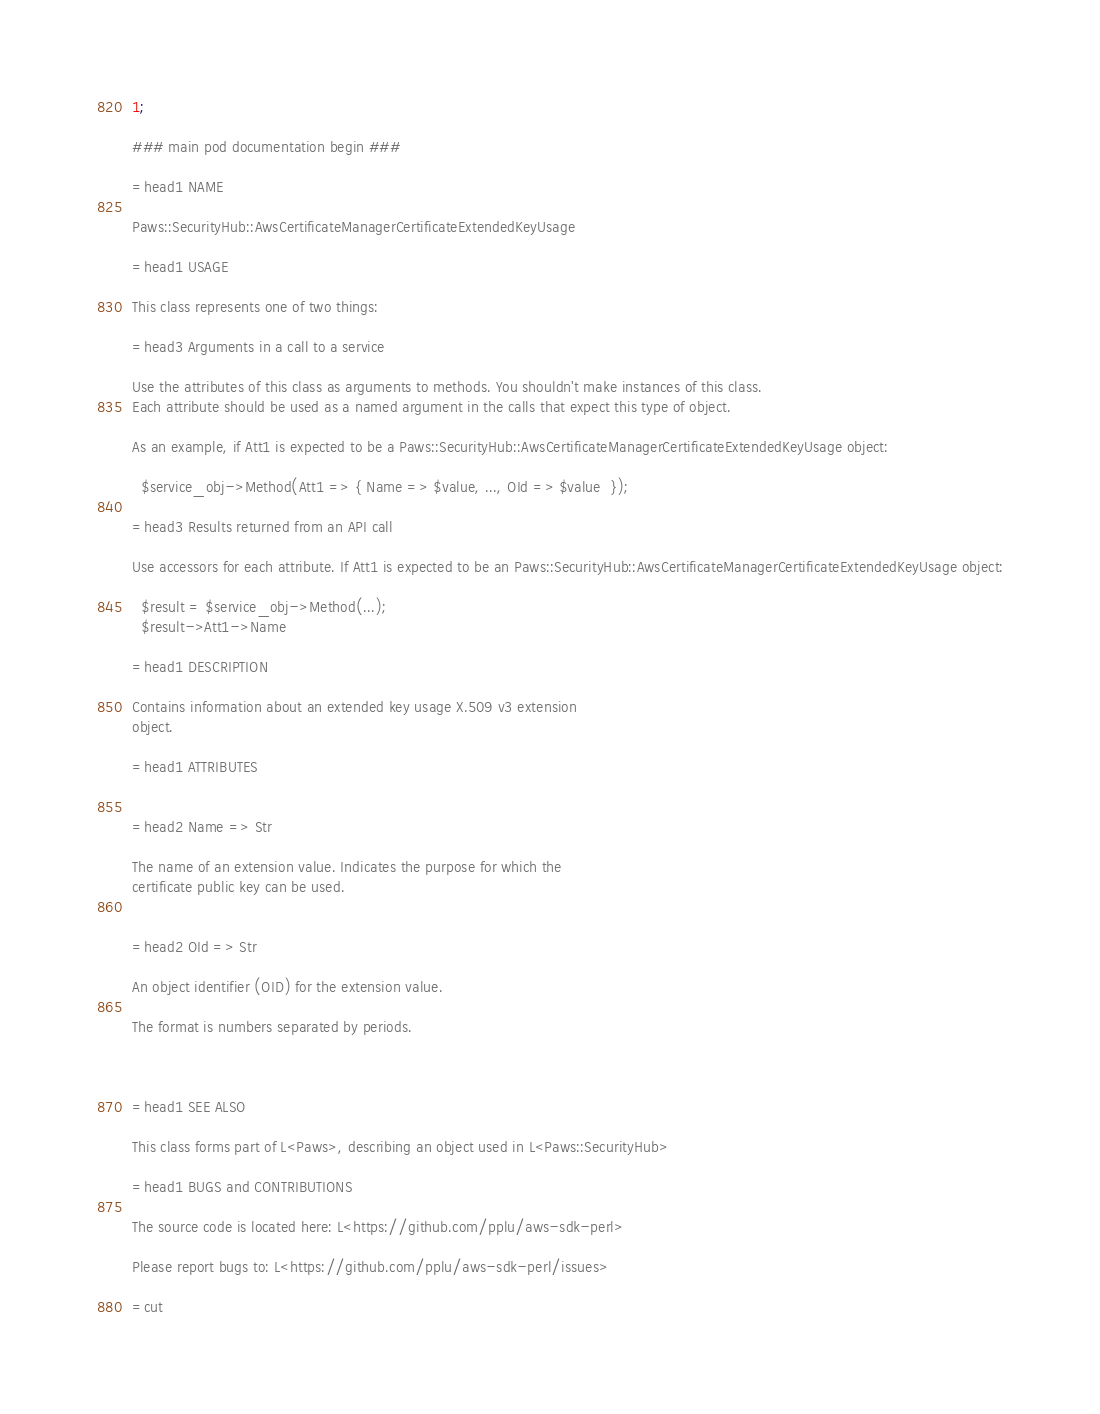<code> <loc_0><loc_0><loc_500><loc_500><_Perl_>1;

### main pod documentation begin ###

=head1 NAME

Paws::SecurityHub::AwsCertificateManagerCertificateExtendedKeyUsage

=head1 USAGE

This class represents one of two things:

=head3 Arguments in a call to a service

Use the attributes of this class as arguments to methods. You shouldn't make instances of this class. 
Each attribute should be used as a named argument in the calls that expect this type of object.

As an example, if Att1 is expected to be a Paws::SecurityHub::AwsCertificateManagerCertificateExtendedKeyUsage object:

  $service_obj->Method(Att1 => { Name => $value, ..., OId => $value  });

=head3 Results returned from an API call

Use accessors for each attribute. If Att1 is expected to be an Paws::SecurityHub::AwsCertificateManagerCertificateExtendedKeyUsage object:

  $result = $service_obj->Method(...);
  $result->Att1->Name

=head1 DESCRIPTION

Contains information about an extended key usage X.509 v3 extension
object.

=head1 ATTRIBUTES


=head2 Name => Str

The name of an extension value. Indicates the purpose for which the
certificate public key can be used.


=head2 OId => Str

An object identifier (OID) for the extension value.

The format is numbers separated by periods.



=head1 SEE ALSO

This class forms part of L<Paws>, describing an object used in L<Paws::SecurityHub>

=head1 BUGS and CONTRIBUTIONS

The source code is located here: L<https://github.com/pplu/aws-sdk-perl>

Please report bugs to: L<https://github.com/pplu/aws-sdk-perl/issues>

=cut

</code> 